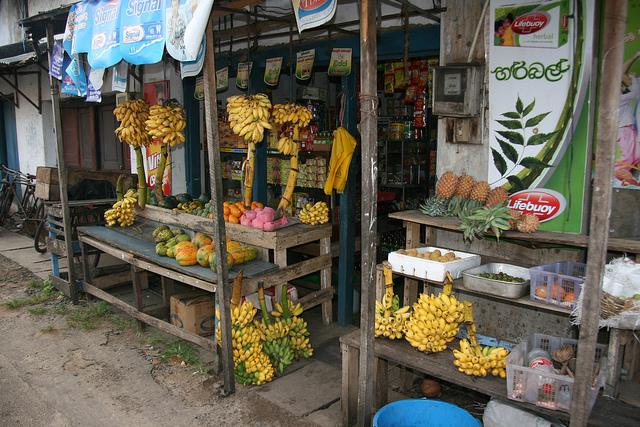What is the brand Lifebuoy selling? soap 